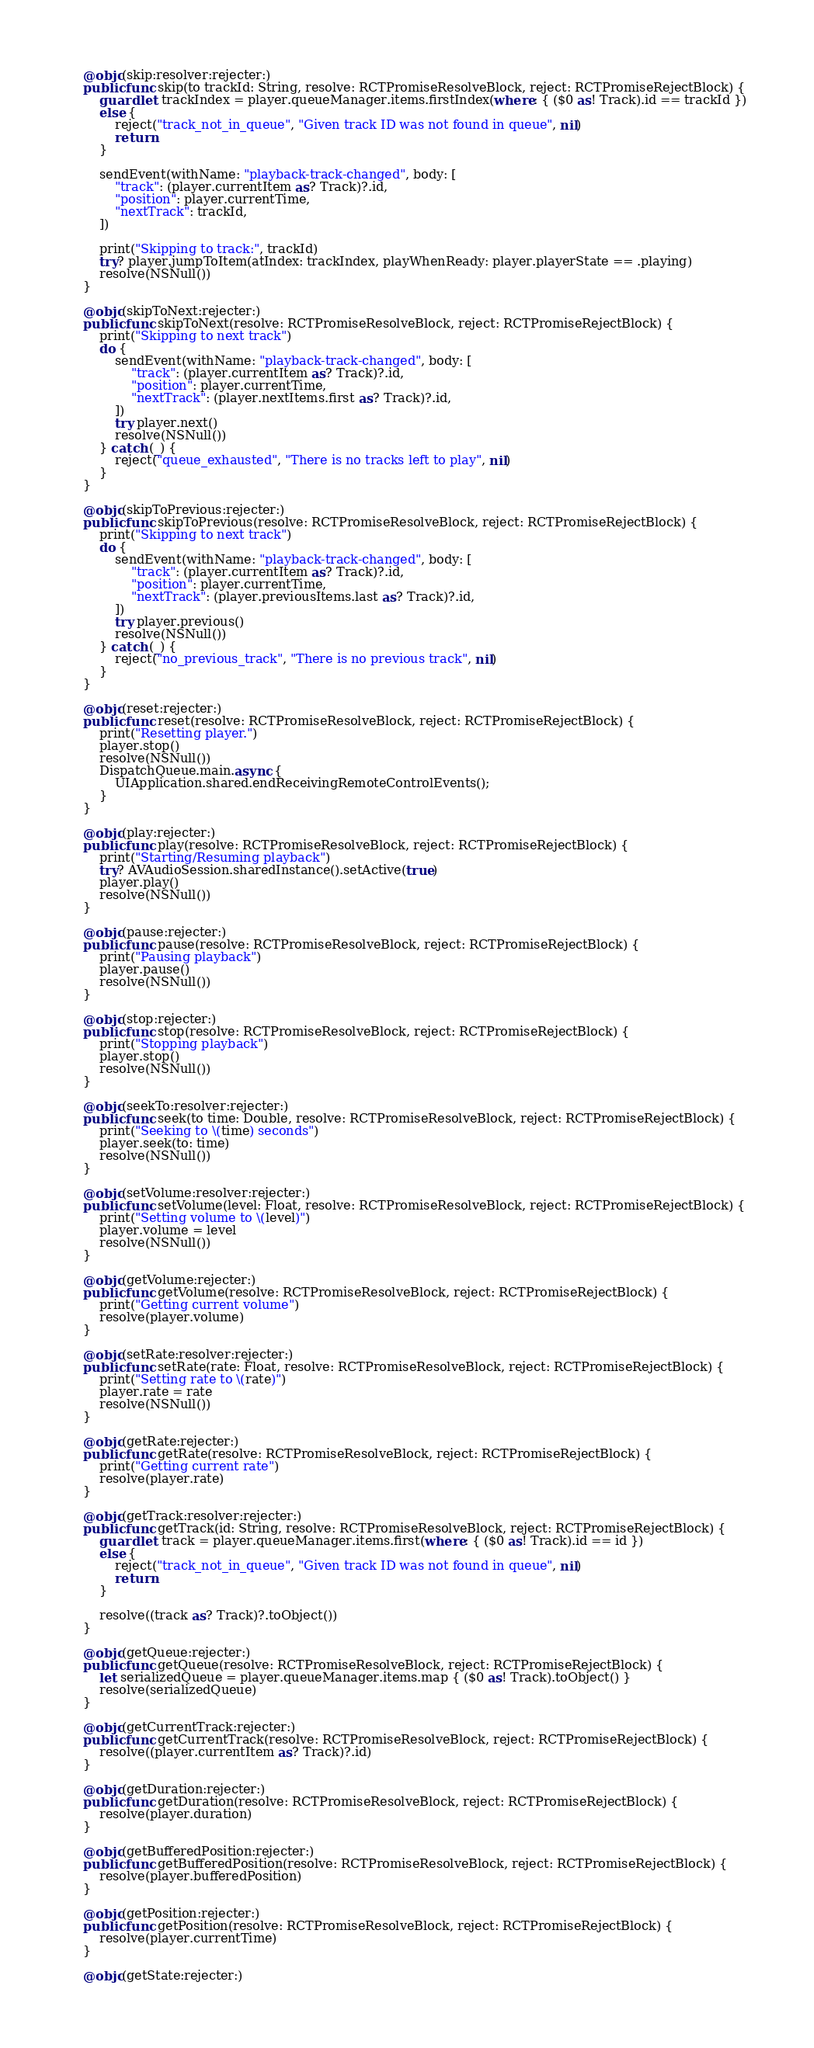Convert code to text. <code><loc_0><loc_0><loc_500><loc_500><_Swift_>    @objc(skip:resolver:rejecter:)
    public func skip(to trackId: String, resolve: RCTPromiseResolveBlock, reject: RCTPromiseRejectBlock) {
        guard let trackIndex = player.queueManager.items.firstIndex(where: { ($0 as! Track).id == trackId })
        else {
            reject("track_not_in_queue", "Given track ID was not found in queue", nil)
            return
        }
        
        sendEvent(withName: "playback-track-changed", body: [
            "track": (player.currentItem as? Track)?.id,
            "position": player.currentTime,
            "nextTrack": trackId,
        ])
        
        print("Skipping to track:", trackId)
        try? player.jumpToItem(atIndex: trackIndex, playWhenReady: player.playerState == .playing)
        resolve(NSNull())
    }
    
    @objc(skipToNext:rejecter:)
    public func skipToNext(resolve: RCTPromiseResolveBlock, reject: RCTPromiseRejectBlock) {
        print("Skipping to next track")
        do {
            sendEvent(withName: "playback-track-changed", body: [
                "track": (player.currentItem as? Track)?.id,
                "position": player.currentTime,
                "nextTrack": (player.nextItems.first as? Track)?.id,
            ])
            try player.next()
            resolve(NSNull())
        } catch (_) {
            reject("queue_exhausted", "There is no tracks left to play", nil)
        }
    }
    
    @objc(skipToPrevious:rejecter:)
    public func skipToPrevious(resolve: RCTPromiseResolveBlock, reject: RCTPromiseRejectBlock) {
        print("Skipping to next track")
        do {
            sendEvent(withName: "playback-track-changed", body: [
                "track": (player.currentItem as? Track)?.id,
                "position": player.currentTime,
                "nextTrack": (player.previousItems.last as? Track)?.id,
            ])
            try player.previous()
            resolve(NSNull())
        } catch (_) {
            reject("no_previous_track", "There is no previous track", nil)
        }
    }
    
    @objc(reset:rejecter:)
    public func reset(resolve: RCTPromiseResolveBlock, reject: RCTPromiseRejectBlock) {
        print("Resetting player.")
        player.stop()
        resolve(NSNull())
        DispatchQueue.main.async {
            UIApplication.shared.endReceivingRemoteControlEvents();
        }
    }
    
    @objc(play:rejecter:)
    public func play(resolve: RCTPromiseResolveBlock, reject: RCTPromiseRejectBlock) {
        print("Starting/Resuming playback")
        try? AVAudioSession.sharedInstance().setActive(true)
        player.play()
        resolve(NSNull())
    }
    
    @objc(pause:rejecter:)
    public func pause(resolve: RCTPromiseResolveBlock, reject: RCTPromiseRejectBlock) {
        print("Pausing playback")
        player.pause()
        resolve(NSNull())
    }
    
    @objc(stop:rejecter:)
    public func stop(resolve: RCTPromiseResolveBlock, reject: RCTPromiseRejectBlock) {
        print("Stopping playback")
        player.stop()
        resolve(NSNull())
    }
    
    @objc(seekTo:resolver:rejecter:)
    public func seek(to time: Double, resolve: RCTPromiseResolveBlock, reject: RCTPromiseRejectBlock) {
        print("Seeking to \(time) seconds")
        player.seek(to: time)
        resolve(NSNull())
    }
    
    @objc(setVolume:resolver:rejecter:)
    public func setVolume(level: Float, resolve: RCTPromiseResolveBlock, reject: RCTPromiseRejectBlock) {
        print("Setting volume to \(level)")
        player.volume = level
        resolve(NSNull())
    }
    
    @objc(getVolume:rejecter:)
    public func getVolume(resolve: RCTPromiseResolveBlock, reject: RCTPromiseRejectBlock) {
        print("Getting current volume")
        resolve(player.volume)
    }
    
    @objc(setRate:resolver:rejecter:)
    public func setRate(rate: Float, resolve: RCTPromiseResolveBlock, reject: RCTPromiseRejectBlock) {
        print("Setting rate to \(rate)")
        player.rate = rate
        resolve(NSNull())
    }
    
    @objc(getRate:rejecter:)
    public func getRate(resolve: RCTPromiseResolveBlock, reject: RCTPromiseRejectBlock) {
        print("Getting current rate")
        resolve(player.rate)
    }
    
    @objc(getTrack:resolver:rejecter:)
    public func getTrack(id: String, resolve: RCTPromiseResolveBlock, reject: RCTPromiseRejectBlock) {
        guard let track = player.queueManager.items.first(where: { ($0 as! Track).id == id })
        else {
            reject("track_not_in_queue", "Given track ID was not found in queue", nil)
            return
        }
        
        resolve((track as? Track)?.toObject())
    }
    
    @objc(getQueue:rejecter:)
    public func getQueue(resolve: RCTPromiseResolveBlock, reject: RCTPromiseRejectBlock) {
        let serializedQueue = player.queueManager.items.map { ($0 as! Track).toObject() }
        resolve(serializedQueue)
    }
    
    @objc(getCurrentTrack:rejecter:)
    public func getCurrentTrack(resolve: RCTPromiseResolveBlock, reject: RCTPromiseRejectBlock) {
        resolve((player.currentItem as? Track)?.id)
    }
    
    @objc(getDuration:rejecter:)
    public func getDuration(resolve: RCTPromiseResolveBlock, reject: RCTPromiseRejectBlock) {
        resolve(player.duration)
    }
    
    @objc(getBufferedPosition:rejecter:)
    public func getBufferedPosition(resolve: RCTPromiseResolveBlock, reject: RCTPromiseRejectBlock) {
        resolve(player.bufferedPosition)
    }
    
    @objc(getPosition:rejecter:)
    public func getPosition(resolve: RCTPromiseResolveBlock, reject: RCTPromiseRejectBlock) {
        resolve(player.currentTime)
    }
    
    @objc(getState:rejecter:)</code> 